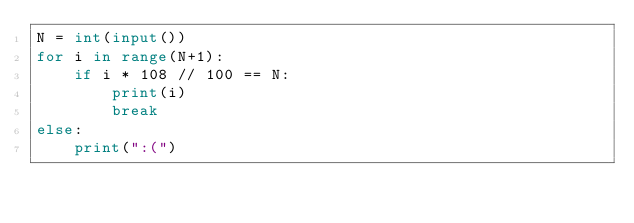Convert code to text. <code><loc_0><loc_0><loc_500><loc_500><_Python_>N = int(input())
for i in range(N+1):
    if i * 108 // 100 == N:
        print(i)
        break
else:
    print(":(")</code> 